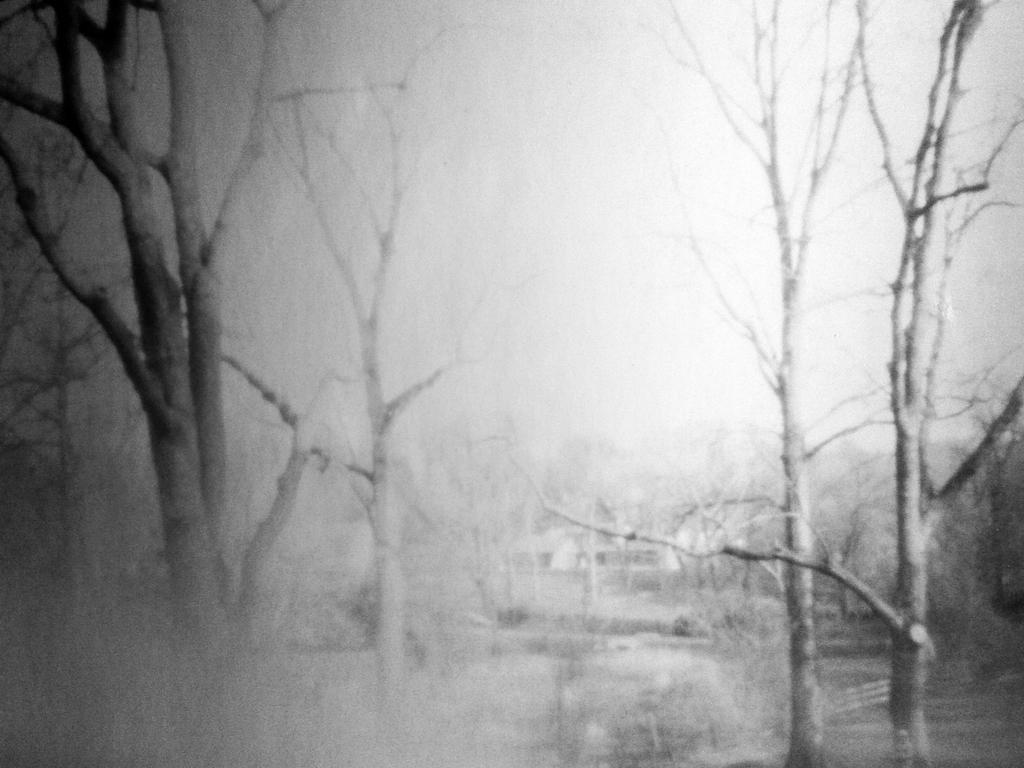Can you describe this image briefly? This is a black and white image and here we can see trees. 